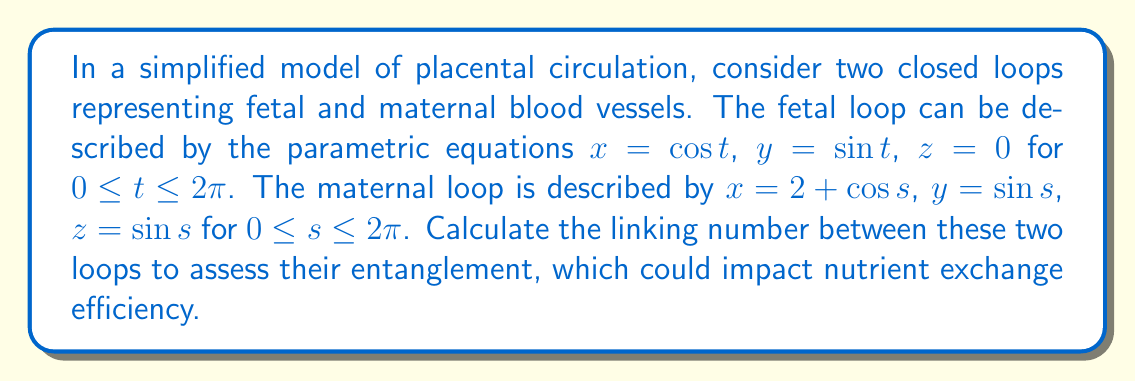Help me with this question. To calculate the linking number between two closed loops, we can use the Gauss linking integral:

$$Lk = \frac{1}{4\pi} \oint_{\gamma_1} \oint_{\gamma_2} \frac{(\mathbf{r}_1 - \mathbf{r}_2) \cdot (d\mathbf{r}_1 \times d\mathbf{r}_2)}{|\mathbf{r}_1 - \mathbf{r}_2|^3}$$

Where $\gamma_1$ and $\gamma_2$ are the two loops, and $\mathbf{r}_1$ and $\mathbf{r}_2$ are position vectors on each loop.

Step 1: Define the position vectors and their derivatives:
$\mathbf{r}_1 = (\cos t, \sin t, 0)$
$d\mathbf{r}_1 = (-\sin t, \cos t, 0) dt$
$\mathbf{r}_2 = (2 + \cos s, \sin s, \sin s)$
$d\mathbf{r}_2 = (-\sin s, \cos s, \cos s) ds$

Step 2: Calculate $\mathbf{r}_1 - \mathbf{r}_2$:
$\mathbf{r}_1 - \mathbf{r}_2 = (\cos t - 2 - \cos s, \sin t - \sin s, -\sin s)$

Step 3: Calculate $d\mathbf{r}_1 \times d\mathbf{r}_2$:
$d\mathbf{r}_1 \times d\mathbf{r}_2 = (\cos t \cos s, \sin t \cos s, -\sin t \sin s - \cos t) dt ds$

Step 4: Calculate $(\mathbf{r}_1 - \mathbf{r}_2) \cdot (d\mathbf{r}_1 \times d\mathbf{r}_2)$:
$(\mathbf{r}_1 - \mathbf{r}_2) \cdot (d\mathbf{r}_1 \times d\mathbf{r}_2) = 
[(\cos t - 2 - \cos s)(\cos t \cos s) + (\sin t - \sin s)(\sin t \cos s) + (-\sin s)(-\sin t \sin s - \cos t)] dt ds$

Step 5: Calculate $|\mathbf{r}_1 - \mathbf{r}_2|^3$:
$|\mathbf{r}_1 - \mathbf{r}_2|^3 = [(\cos t - 2 - \cos s)^2 + (\sin t - \sin s)^2 + \sin^2 s]^{3/2}$

Step 6: Substitute into the Gauss linking integral:
$$Lk = \frac{1}{4\pi} \int_0^{2\pi} \int_0^{2\pi} \frac{(\cos t - 2 - \cos s)(\cos t \cos s) + (\sin t - \sin s)(\sin t \cos s) + \sin s(\sin t \sin s + \cos t)}{[(\cos t - 2 - \cos s)^2 + (\sin t - \sin s)^2 + \sin^2 s]^{3/2}} dt ds$$

Step 7: Evaluate the integral numerically (as it's difficult to solve analytically):
Using numerical integration methods, we find that $Lk \approx 1$.
Answer: $Lk = 1$ 